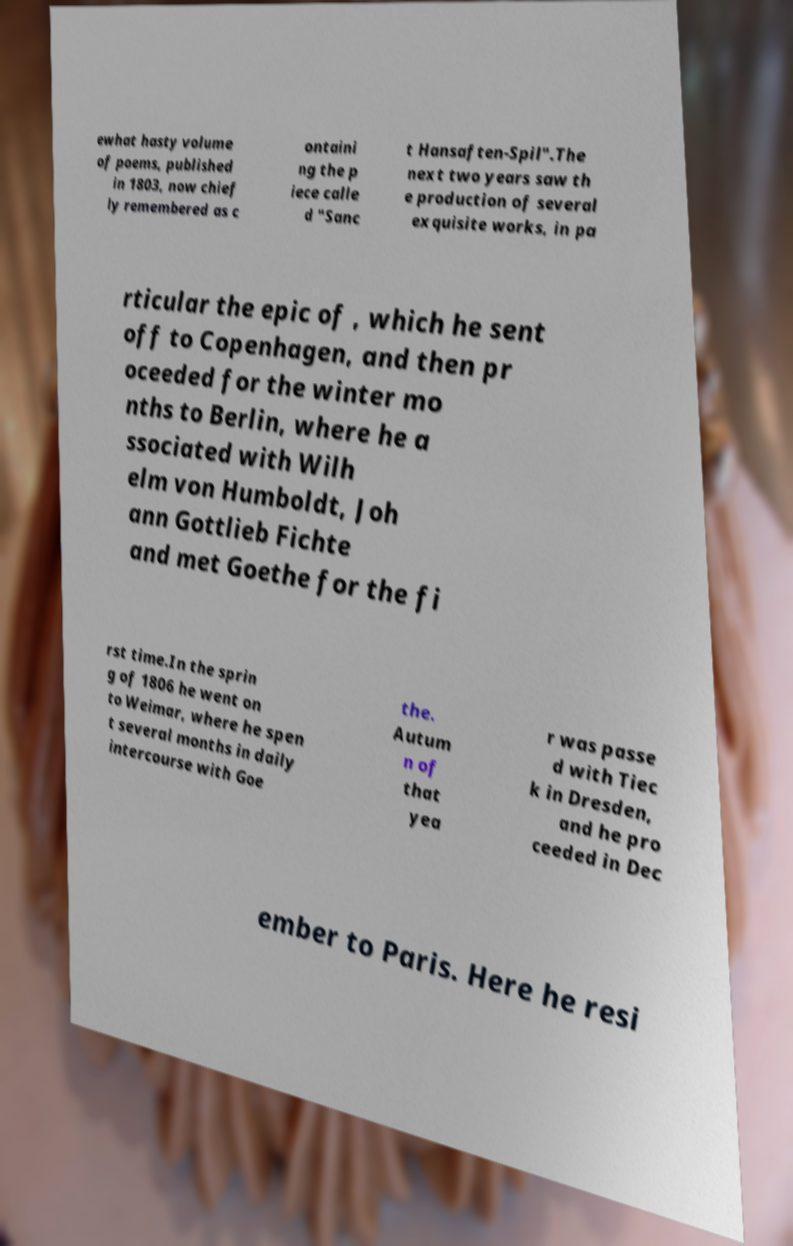Could you assist in decoding the text presented in this image and type it out clearly? ewhat hasty volume of poems, published in 1803, now chief ly remembered as c ontaini ng the p iece calle d "Sanc t Hansaften-Spil".The next two years saw th e production of several exquisite works, in pa rticular the epic of , which he sent off to Copenhagen, and then pr oceeded for the winter mo nths to Berlin, where he a ssociated with Wilh elm von Humboldt, Joh ann Gottlieb Fichte and met Goethe for the fi rst time.In the sprin g of 1806 he went on to Weimar, where he spen t several months in daily intercourse with Goe the. Autum n of that yea r was passe d with Tiec k in Dresden, and he pro ceeded in Dec ember to Paris. Here he resi 